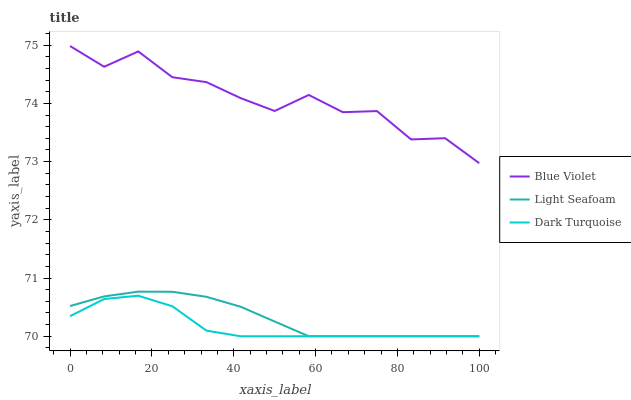Does Light Seafoam have the minimum area under the curve?
Answer yes or no. No. Does Light Seafoam have the maximum area under the curve?
Answer yes or no. No. Is Blue Violet the smoothest?
Answer yes or no. No. Is Light Seafoam the roughest?
Answer yes or no. No. Does Blue Violet have the lowest value?
Answer yes or no. No. Does Light Seafoam have the highest value?
Answer yes or no. No. Is Light Seafoam less than Blue Violet?
Answer yes or no. Yes. Is Blue Violet greater than Light Seafoam?
Answer yes or no. Yes. Does Light Seafoam intersect Blue Violet?
Answer yes or no. No. 